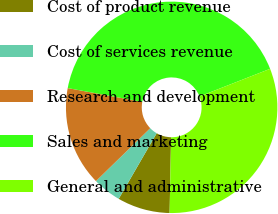<chart> <loc_0><loc_0><loc_500><loc_500><pie_chart><fcel>Cost of product revenue<fcel>Cost of services revenue<fcel>Research and development<fcel>Sales and marketing<fcel>General and administrative<nl><fcel>8.04%<fcel>4.36%<fcel>15.21%<fcel>41.15%<fcel>31.25%<nl></chart> 